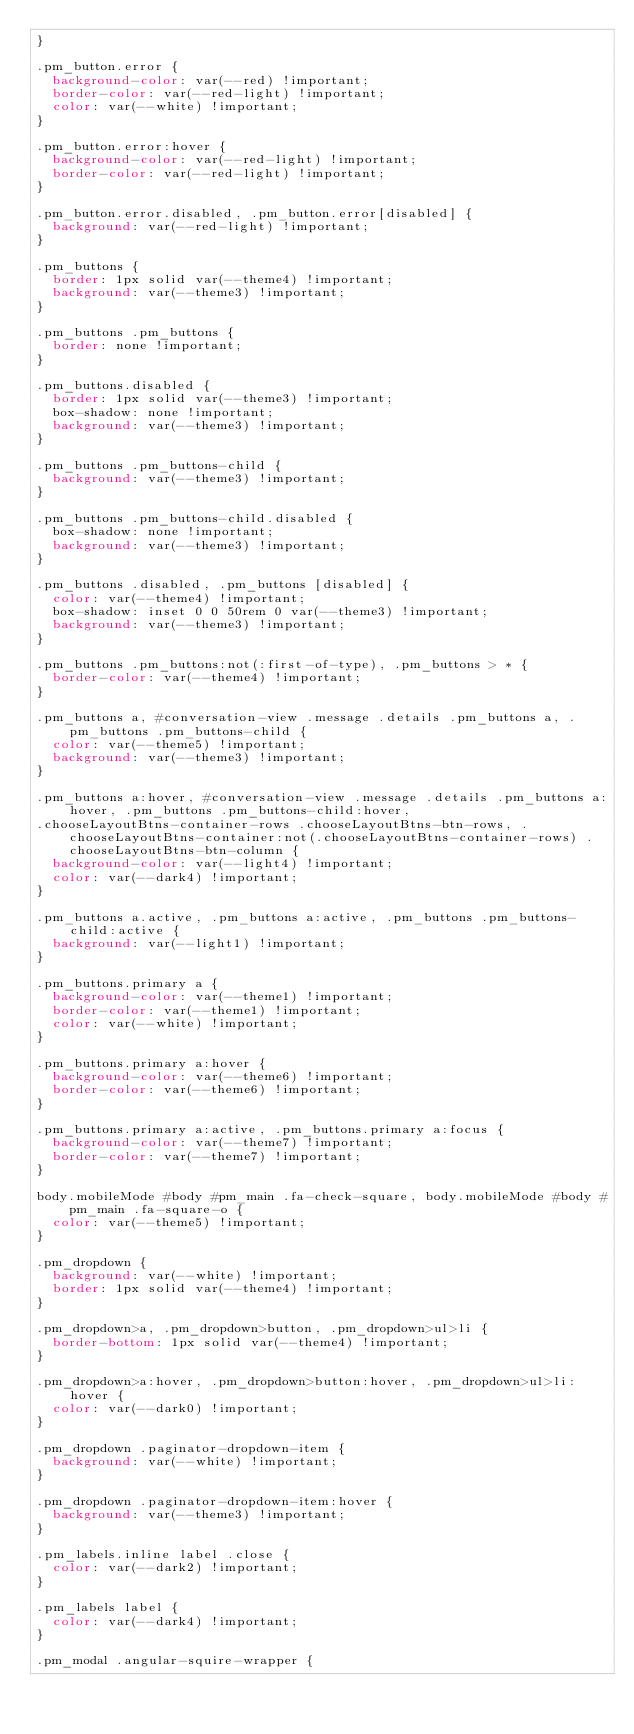Convert code to text. <code><loc_0><loc_0><loc_500><loc_500><_CSS_>}

.pm_button.error {
	background-color: var(--red) !important;
	border-color: var(--red-light) !important;
	color: var(--white) !important;
}

.pm_button.error:hover {
	background-color: var(--red-light) !important;
	border-color: var(--red-light) !important;
}

.pm_button.error.disabled, .pm_button.error[disabled] {
	background: var(--red-light) !important;
}

.pm_buttons {
	border: 1px solid var(--theme4) !important;
	background: var(--theme3) !important;
}

.pm_buttons .pm_buttons {
	border: none !important;
}

.pm_buttons.disabled {
	border: 1px solid var(--theme3) !important;
	box-shadow: none !important;
	background: var(--theme3) !important;
}

.pm_buttons .pm_buttons-child {
	background: var(--theme3) !important;
}

.pm_buttons .pm_buttons-child.disabled {
	box-shadow: none !important;
	background: var(--theme3) !important;
}

.pm_buttons .disabled, .pm_buttons [disabled] {
	color: var(--theme4) !important;
	box-shadow: inset 0 0 50rem 0 var(--theme3) !important;
	background: var(--theme3) !important;
}

.pm_buttons .pm_buttons:not(:first-of-type), .pm_buttons > * {
	border-color: var(--theme4) !important;
}

.pm_buttons a, #conversation-view .message .details .pm_buttons a, .pm_buttons .pm_buttons-child {
	color: var(--theme5) !important;
	background: var(--theme3) !important;
}

.pm_buttons a:hover, #conversation-view .message .details .pm_buttons a:hover, .pm_buttons .pm_buttons-child:hover,
.chooseLayoutBtns-container-rows .chooseLayoutBtns-btn-rows, .chooseLayoutBtns-container:not(.chooseLayoutBtns-container-rows) .chooseLayoutBtns-btn-column {
	background-color: var(--light4) !important;
	color: var(--dark4) !important;
}

.pm_buttons a.active, .pm_buttons a:active, .pm_buttons .pm_buttons-child:active {
	background: var(--light1) !important;
}

.pm_buttons.primary a {
	background-color: var(--theme1) !important;
	border-color: var(--theme1) !important;
	color: var(--white) !important;
}

.pm_buttons.primary a:hover {
	background-color: var(--theme6) !important;
	border-color: var(--theme6) !important;
}

.pm_buttons.primary a:active, .pm_buttons.primary a:focus {
	background-color: var(--theme7) !important;
	border-color: var(--theme7) !important;
}

body.mobileMode #body #pm_main .fa-check-square, body.mobileMode #body #pm_main .fa-square-o {
	color: var(--theme5) !important;
}

.pm_dropdown {
	background: var(--white) !important;
	border: 1px solid var(--theme4) !important;
}

.pm_dropdown>a, .pm_dropdown>button, .pm_dropdown>ul>li {
	border-bottom: 1px solid var(--theme4) !important;
}

.pm_dropdown>a:hover, .pm_dropdown>button:hover, .pm_dropdown>ul>li:hover {
	color: var(--dark0) !important;
}

.pm_dropdown .paginator-dropdown-item {
  background: var(--white) !important;
}

.pm_dropdown .paginator-dropdown-item:hover {
  background: var(--theme3) !important;
}

.pm_labels.inline label .close {
	color: var(--dark2) !important;
}

.pm_labels label {
	color: var(--dark4) !important;
}

.pm_modal .angular-squire-wrapper {</code> 